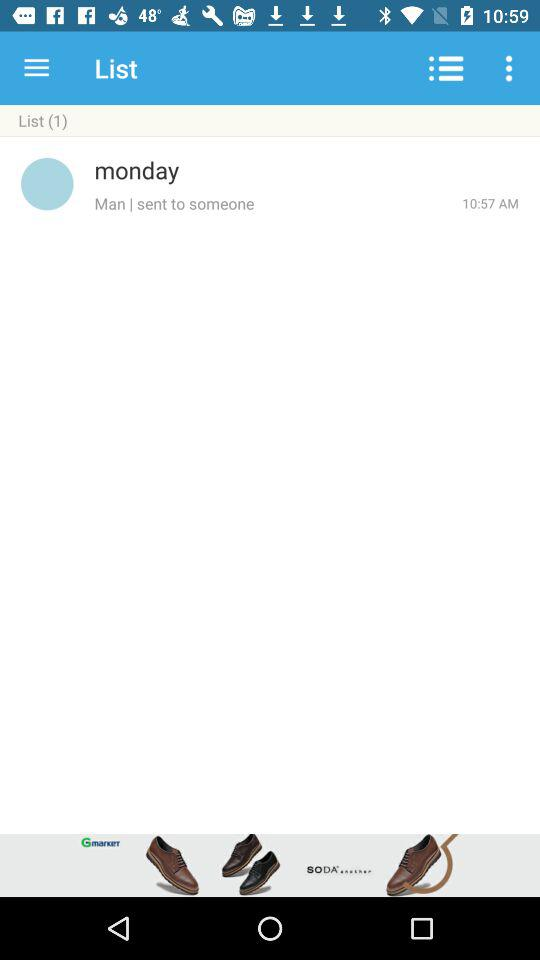What is the shown time? The shown time is 10:57 a.m. 